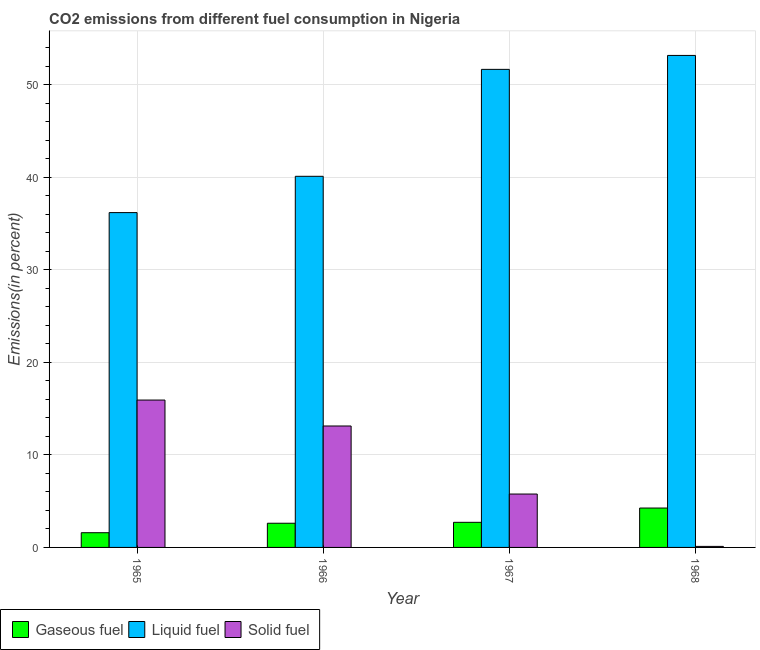How many different coloured bars are there?
Keep it short and to the point. 3. What is the label of the 4th group of bars from the left?
Your answer should be compact. 1968. What is the percentage of solid fuel emission in 1967?
Your response must be concise. 5.77. Across all years, what is the maximum percentage of liquid fuel emission?
Keep it short and to the point. 53.18. Across all years, what is the minimum percentage of solid fuel emission?
Provide a succinct answer. 0.11. In which year was the percentage of gaseous fuel emission maximum?
Ensure brevity in your answer.  1968. In which year was the percentage of liquid fuel emission minimum?
Keep it short and to the point. 1965. What is the total percentage of liquid fuel emission in the graph?
Provide a succinct answer. 181.15. What is the difference between the percentage of liquid fuel emission in 1965 and that in 1968?
Provide a short and direct response. -16.99. What is the difference between the percentage of liquid fuel emission in 1966 and the percentage of solid fuel emission in 1968?
Make the answer very short. -13.06. What is the average percentage of solid fuel emission per year?
Offer a very short reply. 8.73. In the year 1968, what is the difference between the percentage of liquid fuel emission and percentage of solid fuel emission?
Ensure brevity in your answer.  0. What is the ratio of the percentage of gaseous fuel emission in 1967 to that in 1968?
Provide a succinct answer. 0.64. Is the percentage of liquid fuel emission in 1965 less than that in 1966?
Provide a short and direct response. Yes. Is the difference between the percentage of liquid fuel emission in 1965 and 1968 greater than the difference between the percentage of gaseous fuel emission in 1965 and 1968?
Keep it short and to the point. No. What is the difference between the highest and the second highest percentage of gaseous fuel emission?
Make the answer very short. 1.54. What is the difference between the highest and the lowest percentage of liquid fuel emission?
Provide a short and direct response. 16.99. Is the sum of the percentage of liquid fuel emission in 1966 and 1967 greater than the maximum percentage of solid fuel emission across all years?
Ensure brevity in your answer.  Yes. What does the 3rd bar from the left in 1966 represents?
Your answer should be very brief. Solid fuel. What does the 1st bar from the right in 1966 represents?
Provide a succinct answer. Solid fuel. Are all the bars in the graph horizontal?
Your answer should be very brief. No. Are the values on the major ticks of Y-axis written in scientific E-notation?
Make the answer very short. No. Does the graph contain grids?
Your answer should be very brief. Yes. Where does the legend appear in the graph?
Make the answer very short. Bottom left. How are the legend labels stacked?
Your answer should be compact. Horizontal. What is the title of the graph?
Your response must be concise. CO2 emissions from different fuel consumption in Nigeria. Does "Hydroelectric sources" appear as one of the legend labels in the graph?
Your response must be concise. No. What is the label or title of the X-axis?
Your response must be concise. Year. What is the label or title of the Y-axis?
Ensure brevity in your answer.  Emissions(in percent). What is the Emissions(in percent) in Gaseous fuel in 1965?
Keep it short and to the point. 1.59. What is the Emissions(in percent) of Liquid fuel in 1965?
Provide a succinct answer. 36.19. What is the Emissions(in percent) of Solid fuel in 1965?
Offer a very short reply. 15.93. What is the Emissions(in percent) in Gaseous fuel in 1966?
Provide a succinct answer. 2.61. What is the Emissions(in percent) of Liquid fuel in 1966?
Your answer should be very brief. 40.11. What is the Emissions(in percent) in Solid fuel in 1966?
Your answer should be very brief. 13.12. What is the Emissions(in percent) in Gaseous fuel in 1967?
Give a very brief answer. 2.71. What is the Emissions(in percent) in Liquid fuel in 1967?
Your answer should be compact. 51.67. What is the Emissions(in percent) of Solid fuel in 1967?
Make the answer very short. 5.77. What is the Emissions(in percent) of Gaseous fuel in 1968?
Your answer should be compact. 4.26. What is the Emissions(in percent) of Liquid fuel in 1968?
Offer a very short reply. 53.18. What is the Emissions(in percent) in Solid fuel in 1968?
Make the answer very short. 0.11. Across all years, what is the maximum Emissions(in percent) in Gaseous fuel?
Make the answer very short. 4.26. Across all years, what is the maximum Emissions(in percent) in Liquid fuel?
Your response must be concise. 53.18. Across all years, what is the maximum Emissions(in percent) in Solid fuel?
Offer a very short reply. 15.93. Across all years, what is the minimum Emissions(in percent) of Gaseous fuel?
Provide a short and direct response. 1.59. Across all years, what is the minimum Emissions(in percent) of Liquid fuel?
Provide a succinct answer. 36.19. Across all years, what is the minimum Emissions(in percent) of Solid fuel?
Your response must be concise. 0.11. What is the total Emissions(in percent) in Gaseous fuel in the graph?
Your response must be concise. 11.17. What is the total Emissions(in percent) in Liquid fuel in the graph?
Give a very brief answer. 181.15. What is the total Emissions(in percent) in Solid fuel in the graph?
Offer a very short reply. 34.93. What is the difference between the Emissions(in percent) in Gaseous fuel in 1965 and that in 1966?
Keep it short and to the point. -1.02. What is the difference between the Emissions(in percent) of Liquid fuel in 1965 and that in 1966?
Your answer should be very brief. -3.92. What is the difference between the Emissions(in percent) of Solid fuel in 1965 and that in 1966?
Offer a very short reply. 2.8. What is the difference between the Emissions(in percent) of Gaseous fuel in 1965 and that in 1967?
Give a very brief answer. -1.12. What is the difference between the Emissions(in percent) in Liquid fuel in 1965 and that in 1967?
Offer a terse response. -15.48. What is the difference between the Emissions(in percent) in Solid fuel in 1965 and that in 1967?
Offer a very short reply. 10.16. What is the difference between the Emissions(in percent) in Gaseous fuel in 1965 and that in 1968?
Ensure brevity in your answer.  -2.67. What is the difference between the Emissions(in percent) of Liquid fuel in 1965 and that in 1968?
Ensure brevity in your answer.  -16.99. What is the difference between the Emissions(in percent) of Solid fuel in 1965 and that in 1968?
Provide a succinct answer. 15.82. What is the difference between the Emissions(in percent) of Gaseous fuel in 1966 and that in 1967?
Provide a short and direct response. -0.1. What is the difference between the Emissions(in percent) of Liquid fuel in 1966 and that in 1967?
Your response must be concise. -11.56. What is the difference between the Emissions(in percent) of Solid fuel in 1966 and that in 1967?
Your answer should be compact. 7.36. What is the difference between the Emissions(in percent) of Gaseous fuel in 1966 and that in 1968?
Ensure brevity in your answer.  -1.64. What is the difference between the Emissions(in percent) in Liquid fuel in 1966 and that in 1968?
Offer a terse response. -13.06. What is the difference between the Emissions(in percent) of Solid fuel in 1966 and that in 1968?
Provide a short and direct response. 13.01. What is the difference between the Emissions(in percent) of Gaseous fuel in 1967 and that in 1968?
Your answer should be very brief. -1.54. What is the difference between the Emissions(in percent) in Liquid fuel in 1967 and that in 1968?
Give a very brief answer. -1.51. What is the difference between the Emissions(in percent) of Solid fuel in 1967 and that in 1968?
Your response must be concise. 5.66. What is the difference between the Emissions(in percent) of Gaseous fuel in 1965 and the Emissions(in percent) of Liquid fuel in 1966?
Your answer should be very brief. -38.52. What is the difference between the Emissions(in percent) in Gaseous fuel in 1965 and the Emissions(in percent) in Solid fuel in 1966?
Keep it short and to the point. -11.54. What is the difference between the Emissions(in percent) of Liquid fuel in 1965 and the Emissions(in percent) of Solid fuel in 1966?
Provide a succinct answer. 23.07. What is the difference between the Emissions(in percent) in Gaseous fuel in 1965 and the Emissions(in percent) in Liquid fuel in 1967?
Your answer should be compact. -50.08. What is the difference between the Emissions(in percent) of Gaseous fuel in 1965 and the Emissions(in percent) of Solid fuel in 1967?
Provide a succinct answer. -4.18. What is the difference between the Emissions(in percent) in Liquid fuel in 1965 and the Emissions(in percent) in Solid fuel in 1967?
Your answer should be very brief. 30.42. What is the difference between the Emissions(in percent) in Gaseous fuel in 1965 and the Emissions(in percent) in Liquid fuel in 1968?
Provide a succinct answer. -51.59. What is the difference between the Emissions(in percent) of Gaseous fuel in 1965 and the Emissions(in percent) of Solid fuel in 1968?
Provide a short and direct response. 1.48. What is the difference between the Emissions(in percent) in Liquid fuel in 1965 and the Emissions(in percent) in Solid fuel in 1968?
Provide a succinct answer. 36.08. What is the difference between the Emissions(in percent) in Gaseous fuel in 1966 and the Emissions(in percent) in Liquid fuel in 1967?
Offer a very short reply. -49.06. What is the difference between the Emissions(in percent) in Gaseous fuel in 1966 and the Emissions(in percent) in Solid fuel in 1967?
Make the answer very short. -3.16. What is the difference between the Emissions(in percent) of Liquid fuel in 1966 and the Emissions(in percent) of Solid fuel in 1967?
Provide a short and direct response. 34.34. What is the difference between the Emissions(in percent) of Gaseous fuel in 1966 and the Emissions(in percent) of Liquid fuel in 1968?
Provide a succinct answer. -50.56. What is the difference between the Emissions(in percent) of Gaseous fuel in 1966 and the Emissions(in percent) of Solid fuel in 1968?
Keep it short and to the point. 2.5. What is the difference between the Emissions(in percent) in Liquid fuel in 1966 and the Emissions(in percent) in Solid fuel in 1968?
Give a very brief answer. 40. What is the difference between the Emissions(in percent) in Gaseous fuel in 1967 and the Emissions(in percent) in Liquid fuel in 1968?
Give a very brief answer. -50.47. What is the difference between the Emissions(in percent) in Gaseous fuel in 1967 and the Emissions(in percent) in Solid fuel in 1968?
Provide a short and direct response. 2.6. What is the difference between the Emissions(in percent) in Liquid fuel in 1967 and the Emissions(in percent) in Solid fuel in 1968?
Give a very brief answer. 51.56. What is the average Emissions(in percent) in Gaseous fuel per year?
Your response must be concise. 2.79. What is the average Emissions(in percent) of Liquid fuel per year?
Ensure brevity in your answer.  45.29. What is the average Emissions(in percent) of Solid fuel per year?
Your answer should be compact. 8.73. In the year 1965, what is the difference between the Emissions(in percent) of Gaseous fuel and Emissions(in percent) of Liquid fuel?
Offer a very short reply. -34.6. In the year 1965, what is the difference between the Emissions(in percent) in Gaseous fuel and Emissions(in percent) in Solid fuel?
Offer a terse response. -14.34. In the year 1965, what is the difference between the Emissions(in percent) in Liquid fuel and Emissions(in percent) in Solid fuel?
Provide a succinct answer. 20.26. In the year 1966, what is the difference between the Emissions(in percent) of Gaseous fuel and Emissions(in percent) of Liquid fuel?
Your response must be concise. -37.5. In the year 1966, what is the difference between the Emissions(in percent) in Gaseous fuel and Emissions(in percent) in Solid fuel?
Offer a terse response. -10.51. In the year 1966, what is the difference between the Emissions(in percent) in Liquid fuel and Emissions(in percent) in Solid fuel?
Provide a short and direct response. 26.99. In the year 1967, what is the difference between the Emissions(in percent) of Gaseous fuel and Emissions(in percent) of Liquid fuel?
Your answer should be compact. -48.96. In the year 1967, what is the difference between the Emissions(in percent) in Gaseous fuel and Emissions(in percent) in Solid fuel?
Keep it short and to the point. -3.06. In the year 1967, what is the difference between the Emissions(in percent) in Liquid fuel and Emissions(in percent) in Solid fuel?
Offer a terse response. 45.9. In the year 1968, what is the difference between the Emissions(in percent) of Gaseous fuel and Emissions(in percent) of Liquid fuel?
Your response must be concise. -48.92. In the year 1968, what is the difference between the Emissions(in percent) in Gaseous fuel and Emissions(in percent) in Solid fuel?
Offer a very short reply. 4.15. In the year 1968, what is the difference between the Emissions(in percent) of Liquid fuel and Emissions(in percent) of Solid fuel?
Your answer should be compact. 53.07. What is the ratio of the Emissions(in percent) of Gaseous fuel in 1965 to that in 1966?
Offer a terse response. 0.61. What is the ratio of the Emissions(in percent) of Liquid fuel in 1965 to that in 1966?
Offer a terse response. 0.9. What is the ratio of the Emissions(in percent) in Solid fuel in 1965 to that in 1966?
Offer a terse response. 1.21. What is the ratio of the Emissions(in percent) in Gaseous fuel in 1965 to that in 1967?
Ensure brevity in your answer.  0.59. What is the ratio of the Emissions(in percent) in Liquid fuel in 1965 to that in 1967?
Your answer should be compact. 0.7. What is the ratio of the Emissions(in percent) of Solid fuel in 1965 to that in 1967?
Provide a short and direct response. 2.76. What is the ratio of the Emissions(in percent) in Gaseous fuel in 1965 to that in 1968?
Offer a terse response. 0.37. What is the ratio of the Emissions(in percent) in Liquid fuel in 1965 to that in 1968?
Your answer should be compact. 0.68. What is the ratio of the Emissions(in percent) in Solid fuel in 1965 to that in 1968?
Your answer should be compact. 144.08. What is the ratio of the Emissions(in percent) in Gaseous fuel in 1966 to that in 1967?
Keep it short and to the point. 0.96. What is the ratio of the Emissions(in percent) of Liquid fuel in 1966 to that in 1967?
Ensure brevity in your answer.  0.78. What is the ratio of the Emissions(in percent) of Solid fuel in 1966 to that in 1967?
Keep it short and to the point. 2.27. What is the ratio of the Emissions(in percent) of Gaseous fuel in 1966 to that in 1968?
Your answer should be compact. 0.61. What is the ratio of the Emissions(in percent) of Liquid fuel in 1966 to that in 1968?
Keep it short and to the point. 0.75. What is the ratio of the Emissions(in percent) in Solid fuel in 1966 to that in 1968?
Offer a very short reply. 118.72. What is the ratio of the Emissions(in percent) of Gaseous fuel in 1967 to that in 1968?
Offer a terse response. 0.64. What is the ratio of the Emissions(in percent) in Liquid fuel in 1967 to that in 1968?
Your answer should be very brief. 0.97. What is the ratio of the Emissions(in percent) of Solid fuel in 1967 to that in 1968?
Make the answer very short. 52.19. What is the difference between the highest and the second highest Emissions(in percent) in Gaseous fuel?
Make the answer very short. 1.54. What is the difference between the highest and the second highest Emissions(in percent) of Liquid fuel?
Provide a short and direct response. 1.51. What is the difference between the highest and the second highest Emissions(in percent) of Solid fuel?
Ensure brevity in your answer.  2.8. What is the difference between the highest and the lowest Emissions(in percent) in Gaseous fuel?
Provide a short and direct response. 2.67. What is the difference between the highest and the lowest Emissions(in percent) of Liquid fuel?
Provide a succinct answer. 16.99. What is the difference between the highest and the lowest Emissions(in percent) of Solid fuel?
Keep it short and to the point. 15.82. 